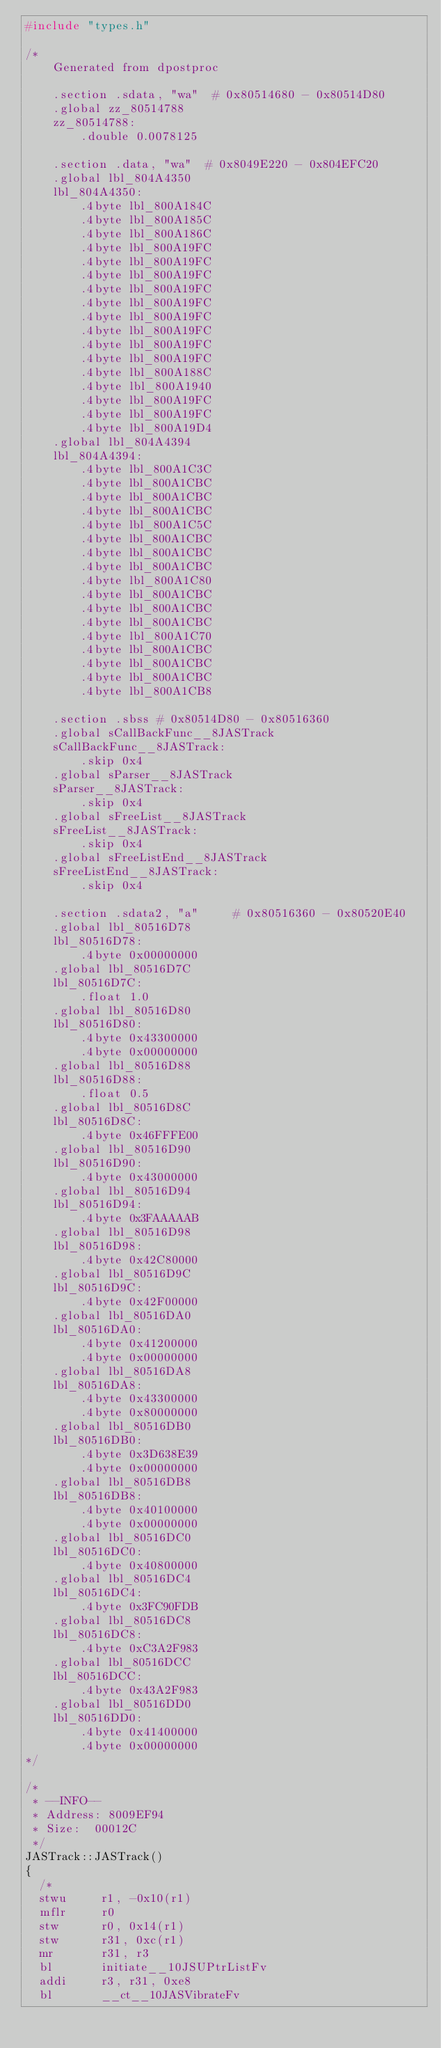<code> <loc_0><loc_0><loc_500><loc_500><_C++_>#include "types.h"

/*
    Generated from dpostproc

    .section .sdata, "wa"  # 0x80514680 - 0x80514D80
    .global zz_80514788
    zz_80514788:
        .double 0.0078125

    .section .data, "wa"  # 0x8049E220 - 0x804EFC20
    .global lbl_804A4350
    lbl_804A4350:
        .4byte lbl_800A184C
        .4byte lbl_800A185C
        .4byte lbl_800A186C
        .4byte lbl_800A19FC
        .4byte lbl_800A19FC
        .4byte lbl_800A19FC
        .4byte lbl_800A19FC
        .4byte lbl_800A19FC
        .4byte lbl_800A19FC
        .4byte lbl_800A19FC
        .4byte lbl_800A19FC
        .4byte lbl_800A19FC
        .4byte lbl_800A188C
        .4byte lbl_800A1940
        .4byte lbl_800A19FC
        .4byte lbl_800A19FC
        .4byte lbl_800A19D4
    .global lbl_804A4394
    lbl_804A4394:
        .4byte lbl_800A1C3C
        .4byte lbl_800A1CBC
        .4byte lbl_800A1CBC
        .4byte lbl_800A1CBC
        .4byte lbl_800A1C5C
        .4byte lbl_800A1CBC
        .4byte lbl_800A1CBC
        .4byte lbl_800A1CBC
        .4byte lbl_800A1C80
        .4byte lbl_800A1CBC
        .4byte lbl_800A1CBC
        .4byte lbl_800A1CBC
        .4byte lbl_800A1C70
        .4byte lbl_800A1CBC
        .4byte lbl_800A1CBC
        .4byte lbl_800A1CBC
        .4byte lbl_800A1CB8

    .section .sbss # 0x80514D80 - 0x80516360
    .global sCallBackFunc__8JASTrack
    sCallBackFunc__8JASTrack:
        .skip 0x4
    .global sParser__8JASTrack
    sParser__8JASTrack:
        .skip 0x4
    .global sFreeList__8JASTrack
    sFreeList__8JASTrack:
        .skip 0x4
    .global sFreeListEnd__8JASTrack
    sFreeListEnd__8JASTrack:
        .skip 0x4

    .section .sdata2, "a"     # 0x80516360 - 0x80520E40
    .global lbl_80516D78
    lbl_80516D78:
        .4byte 0x00000000
    .global lbl_80516D7C
    lbl_80516D7C:
        .float 1.0
    .global lbl_80516D80
    lbl_80516D80:
        .4byte 0x43300000
        .4byte 0x00000000
    .global lbl_80516D88
    lbl_80516D88:
        .float 0.5
    .global lbl_80516D8C
    lbl_80516D8C:
        .4byte 0x46FFFE00
    .global lbl_80516D90
    lbl_80516D90:
        .4byte 0x43000000
    .global lbl_80516D94
    lbl_80516D94:
        .4byte 0x3FAAAAAB
    .global lbl_80516D98
    lbl_80516D98:
        .4byte 0x42C80000
    .global lbl_80516D9C
    lbl_80516D9C:
        .4byte 0x42F00000
    .global lbl_80516DA0
    lbl_80516DA0:
        .4byte 0x41200000
        .4byte 0x00000000
    .global lbl_80516DA8
    lbl_80516DA8:
        .4byte 0x43300000
        .4byte 0x80000000
    .global lbl_80516DB0
    lbl_80516DB0:
        .4byte 0x3D638E39
        .4byte 0x00000000
    .global lbl_80516DB8
    lbl_80516DB8:
        .4byte 0x40100000
        .4byte 0x00000000
    .global lbl_80516DC0
    lbl_80516DC0:
        .4byte 0x40800000
    .global lbl_80516DC4
    lbl_80516DC4:
        .4byte 0x3FC90FDB
    .global lbl_80516DC8
    lbl_80516DC8:
        .4byte 0xC3A2F983
    .global lbl_80516DCC
    lbl_80516DCC:
        .4byte 0x43A2F983
    .global lbl_80516DD0
    lbl_80516DD0:
        .4byte 0x41400000
        .4byte 0x00000000
*/

/*
 * --INFO--
 * Address:	8009EF94
 * Size:	00012C
 */
JASTrack::JASTrack()
{
	/*
	stwu     r1, -0x10(r1)
	mflr     r0
	stw      r0, 0x14(r1)
	stw      r31, 0xc(r1)
	mr       r31, r3
	bl       initiate__10JSUPtrListFv
	addi     r3, r31, 0xe8
	bl       __ct__10JASVibrateFv</code> 